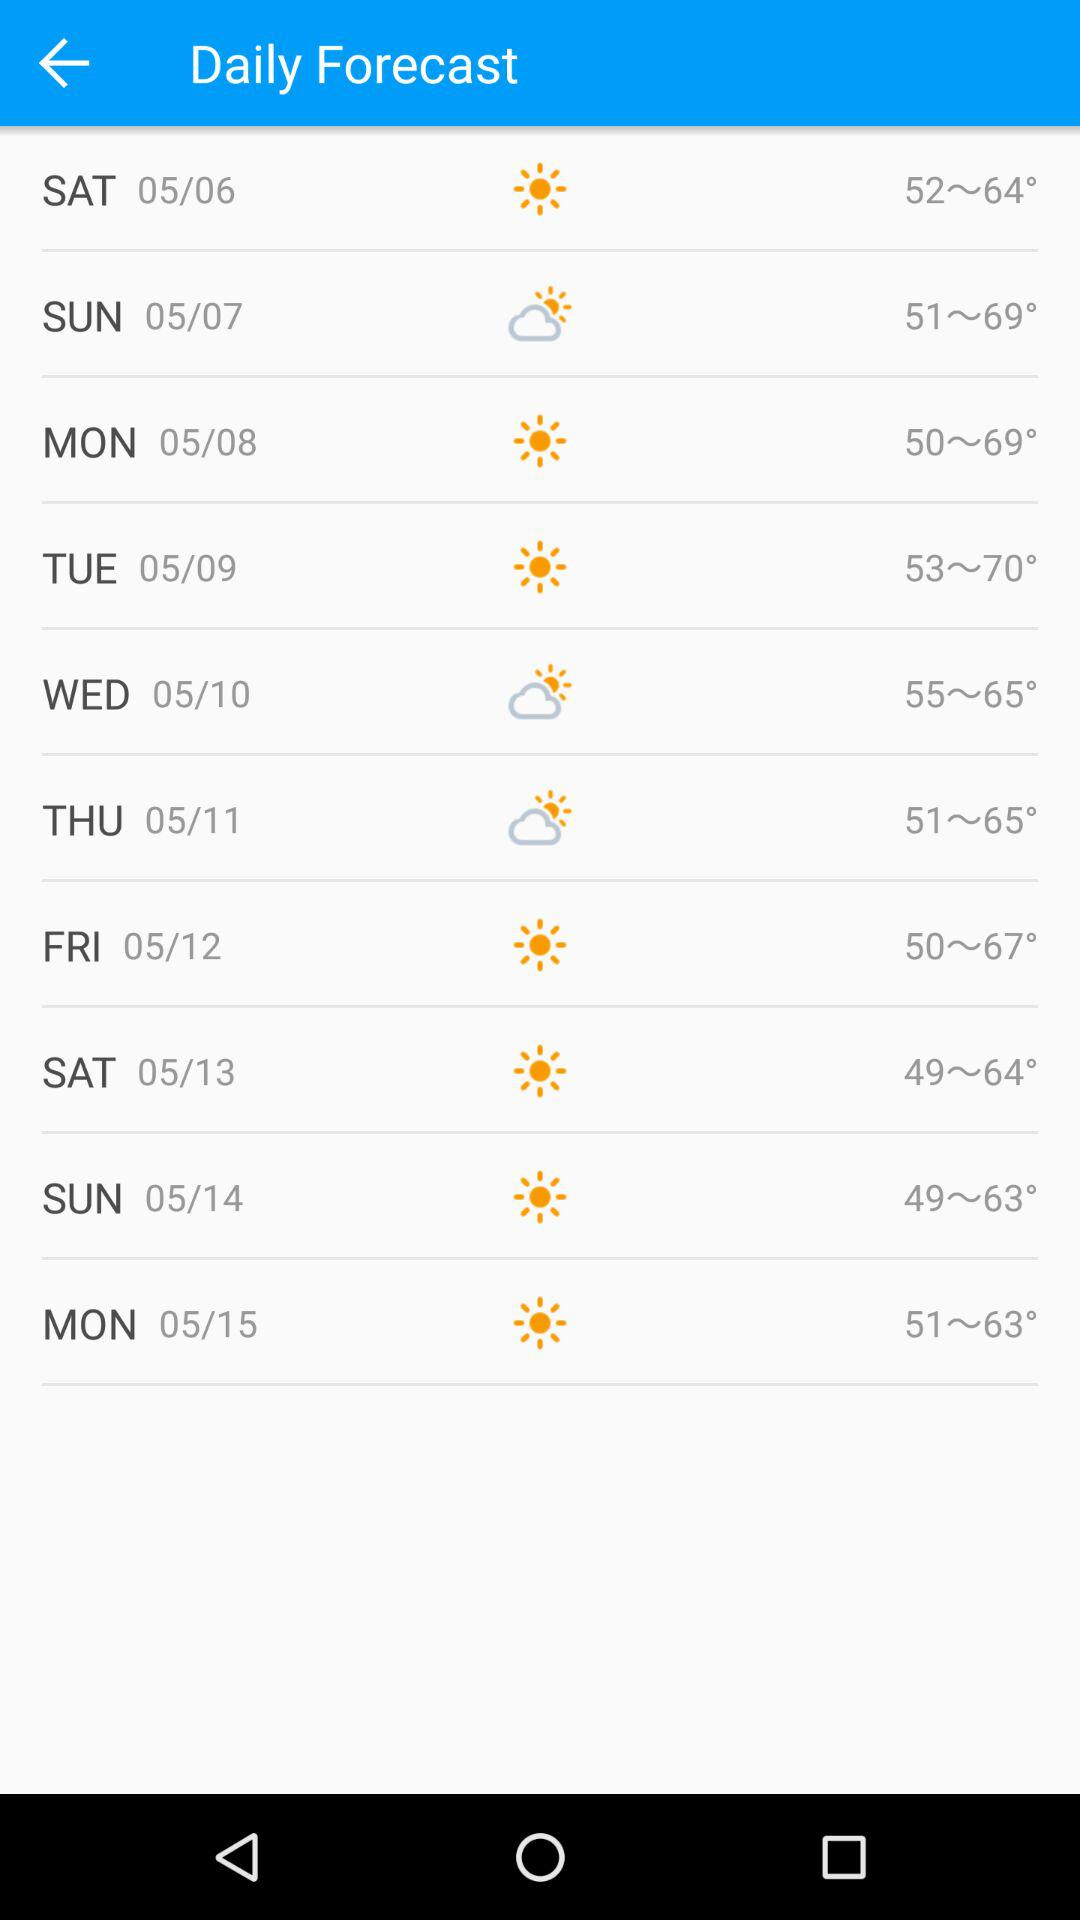What is the temperature range on "Wednesday"? The temperature range is 55~65°. 